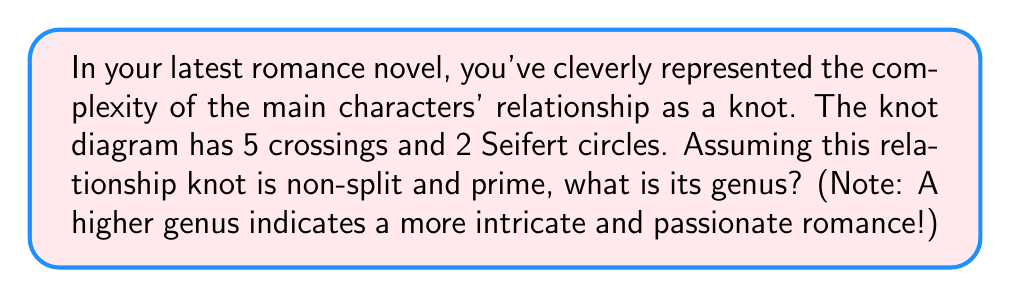Can you solve this math problem? Let's approach this step-by-step:

1) First, recall the formula for the genus of a knot:

   $$g = \frac{1}{2}(c - s + 1)$$

   Where $g$ is the genus, $c$ is the number of crossings, and $s$ is the number of Seifert circles.

2) We're given that:
   - Number of crossings, $c = 5$
   - Number of Seifert circles, $s = 2$

3) Let's substitute these values into our formula:

   $$g = \frac{1}{2}(5 - 2 + 1)$$

4) Simplify inside the parentheses:

   $$g = \frac{1}{2}(4)$$

5) Calculate the final result:

   $$g = 2$$

6) Interpret the result: A genus of 2 suggests a relationship with moderate complexity. It's not a simple, straightforward romance (which would have a genus of 0 or 1), but it's also not an extremely convoluted one (which might have a higher genus).
Answer: 2 